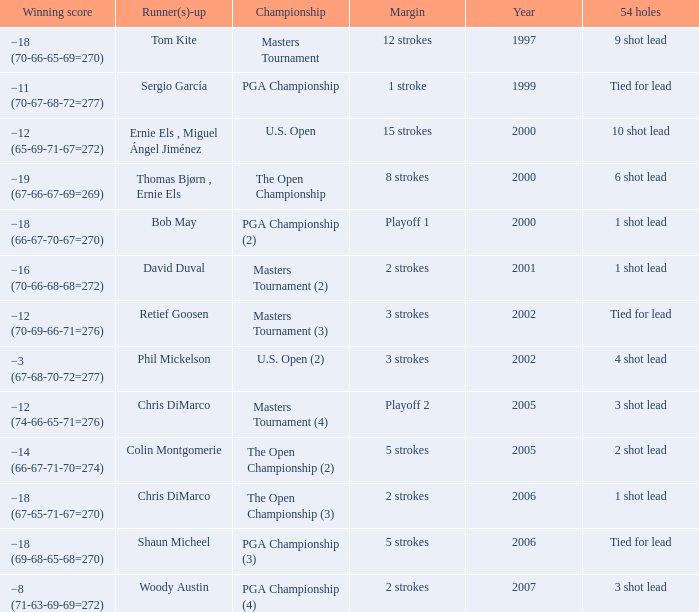Parse the table in full. {'header': ['Winning score', 'Runner(s)-up', 'Championship', 'Margin', 'Year', '54 holes'], 'rows': [['−18 (70-66-65-69=270)', 'Tom Kite', 'Masters Tournament', '12 strokes', '1997', '9 shot lead'], ['−11 (70-67-68-72=277)', 'Sergio García', 'PGA Championship', '1 stroke', '1999', 'Tied for lead'], ['−12 (65-69-71-67=272)', 'Ernie Els , Miguel Ángel Jiménez', 'U.S. Open', '15 strokes', '2000', '10 shot lead'], ['−19 (67-66-67-69=269)', 'Thomas Bjørn , Ernie Els', 'The Open Championship', '8 strokes', '2000', '6 shot lead'], ['−18 (66-67-70-67=270)', 'Bob May', 'PGA Championship (2)', 'Playoff 1', '2000', '1 shot lead'], ['−16 (70-66-68-68=272)', 'David Duval', 'Masters Tournament (2)', '2 strokes', '2001', '1 shot lead'], ['−12 (70-69-66-71=276)', 'Retief Goosen', 'Masters Tournament (3)', '3 strokes', '2002', 'Tied for lead'], ['−3 (67-68-70-72=277)', 'Phil Mickelson', 'U.S. Open (2)', '3 strokes', '2002', '4 shot lead'], ['−12 (74-66-65-71=276)', 'Chris DiMarco', 'Masters Tournament (4)', 'Playoff 2', '2005', '3 shot lead'], ['−14 (66-67-71-70=274)', 'Colin Montgomerie', 'The Open Championship (2)', '5 strokes', '2005', '2 shot lead'], ['−18 (67-65-71-67=270)', 'Chris DiMarco', 'The Open Championship (3)', '2 strokes', '2006', '1 shot lead'], ['−18 (69-68-65-68=270)', 'Shaun Micheel', 'PGA Championship (3)', '5 strokes', '2006', 'Tied for lead'], ['−8 (71-63-69-69=272)', 'Woody Austin', 'PGA Championship (4)', '2 strokes', '2007', '3 shot lead']]}  what's the championship where 54 holes is 1 shot lead and runner(s)-up is chris dimarco The Open Championship (3). 